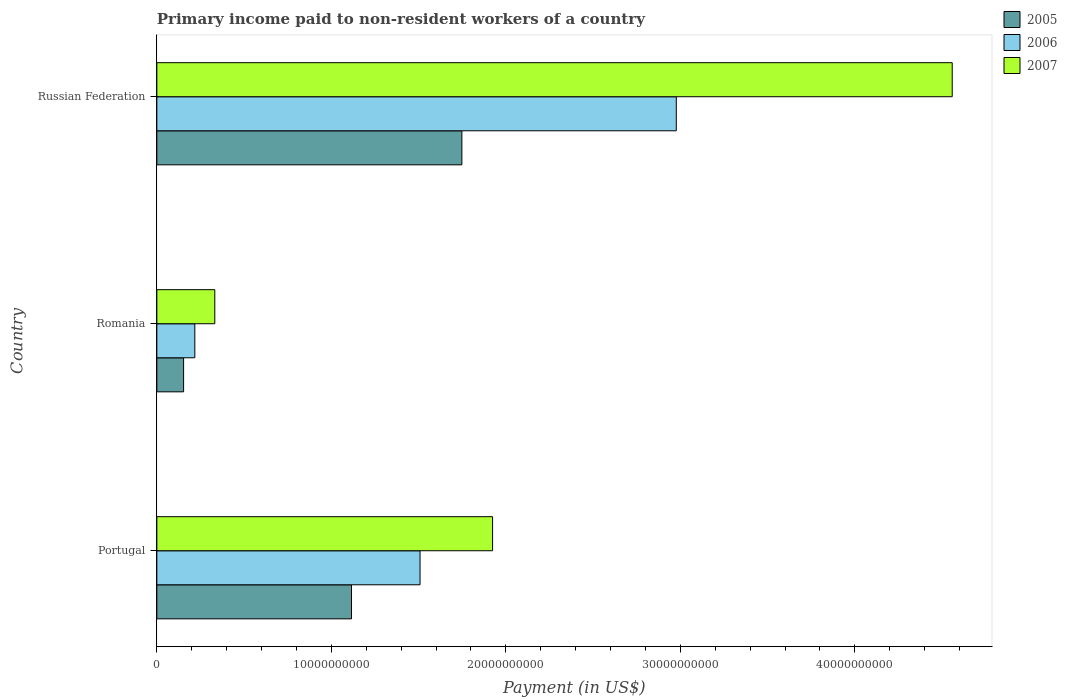How many different coloured bars are there?
Make the answer very short. 3. Are the number of bars per tick equal to the number of legend labels?
Your response must be concise. Yes. Are the number of bars on each tick of the Y-axis equal?
Offer a terse response. Yes. How many bars are there on the 2nd tick from the top?
Ensure brevity in your answer.  3. What is the amount paid to workers in 2005 in Russian Federation?
Your response must be concise. 1.75e+1. Across all countries, what is the maximum amount paid to workers in 2007?
Offer a very short reply. 4.56e+1. Across all countries, what is the minimum amount paid to workers in 2007?
Offer a terse response. 3.32e+09. In which country was the amount paid to workers in 2005 maximum?
Your answer should be very brief. Russian Federation. In which country was the amount paid to workers in 2007 minimum?
Keep it short and to the point. Romania. What is the total amount paid to workers in 2005 in the graph?
Provide a succinct answer. 3.02e+1. What is the difference between the amount paid to workers in 2007 in Portugal and that in Russian Federation?
Offer a very short reply. -2.63e+1. What is the difference between the amount paid to workers in 2007 in Romania and the amount paid to workers in 2005 in Russian Federation?
Your response must be concise. -1.42e+1. What is the average amount paid to workers in 2005 per country?
Provide a short and direct response. 1.01e+1. What is the difference between the amount paid to workers in 2006 and amount paid to workers in 2005 in Romania?
Your answer should be very brief. 6.44e+08. In how many countries, is the amount paid to workers in 2007 greater than 12000000000 US$?
Ensure brevity in your answer.  2. What is the ratio of the amount paid to workers in 2007 in Portugal to that in Romania?
Keep it short and to the point. 5.79. Is the amount paid to workers in 2006 in Romania less than that in Russian Federation?
Your answer should be very brief. Yes. What is the difference between the highest and the second highest amount paid to workers in 2007?
Offer a terse response. 2.63e+1. What is the difference between the highest and the lowest amount paid to workers in 2007?
Your response must be concise. 4.23e+1. Is the sum of the amount paid to workers in 2006 in Romania and Russian Federation greater than the maximum amount paid to workers in 2005 across all countries?
Provide a succinct answer. Yes. What does the 1st bar from the bottom in Portugal represents?
Offer a terse response. 2005. How many bars are there?
Your answer should be compact. 9. Are all the bars in the graph horizontal?
Give a very brief answer. Yes. How many countries are there in the graph?
Your answer should be very brief. 3. What is the difference between two consecutive major ticks on the X-axis?
Your response must be concise. 1.00e+1. Does the graph contain grids?
Your response must be concise. No. Where does the legend appear in the graph?
Offer a terse response. Top right. How many legend labels are there?
Provide a succinct answer. 3. How are the legend labels stacked?
Your answer should be compact. Vertical. What is the title of the graph?
Ensure brevity in your answer.  Primary income paid to non-resident workers of a country. What is the label or title of the X-axis?
Make the answer very short. Payment (in US$). What is the label or title of the Y-axis?
Your response must be concise. Country. What is the Payment (in US$) of 2005 in Portugal?
Ensure brevity in your answer.  1.12e+1. What is the Payment (in US$) of 2006 in Portugal?
Provide a succinct answer. 1.51e+1. What is the Payment (in US$) in 2007 in Portugal?
Provide a short and direct response. 1.92e+1. What is the Payment (in US$) in 2005 in Romania?
Your answer should be very brief. 1.53e+09. What is the Payment (in US$) in 2006 in Romania?
Ensure brevity in your answer.  2.18e+09. What is the Payment (in US$) in 2007 in Romania?
Give a very brief answer. 3.32e+09. What is the Payment (in US$) in 2005 in Russian Federation?
Give a very brief answer. 1.75e+1. What is the Payment (in US$) of 2006 in Russian Federation?
Offer a terse response. 2.98e+1. What is the Payment (in US$) of 2007 in Russian Federation?
Keep it short and to the point. 4.56e+1. Across all countries, what is the maximum Payment (in US$) in 2005?
Ensure brevity in your answer.  1.75e+1. Across all countries, what is the maximum Payment (in US$) in 2006?
Offer a terse response. 2.98e+1. Across all countries, what is the maximum Payment (in US$) of 2007?
Your answer should be very brief. 4.56e+1. Across all countries, what is the minimum Payment (in US$) of 2005?
Provide a short and direct response. 1.53e+09. Across all countries, what is the minimum Payment (in US$) in 2006?
Keep it short and to the point. 2.18e+09. Across all countries, what is the minimum Payment (in US$) of 2007?
Your answer should be compact. 3.32e+09. What is the total Payment (in US$) in 2005 in the graph?
Offer a very short reply. 3.02e+1. What is the total Payment (in US$) of 2006 in the graph?
Your response must be concise. 4.70e+1. What is the total Payment (in US$) of 2007 in the graph?
Offer a very short reply. 6.81e+1. What is the difference between the Payment (in US$) of 2005 in Portugal and that in Romania?
Ensure brevity in your answer.  9.62e+09. What is the difference between the Payment (in US$) in 2006 in Portugal and that in Romania?
Your answer should be compact. 1.29e+1. What is the difference between the Payment (in US$) in 2007 in Portugal and that in Romania?
Keep it short and to the point. 1.59e+1. What is the difference between the Payment (in US$) of 2005 in Portugal and that in Russian Federation?
Offer a very short reply. -6.33e+09. What is the difference between the Payment (in US$) in 2006 in Portugal and that in Russian Federation?
Give a very brief answer. -1.47e+1. What is the difference between the Payment (in US$) in 2007 in Portugal and that in Russian Federation?
Make the answer very short. -2.63e+1. What is the difference between the Payment (in US$) of 2005 in Romania and that in Russian Federation?
Provide a succinct answer. -1.59e+1. What is the difference between the Payment (in US$) of 2006 in Romania and that in Russian Federation?
Offer a terse response. -2.76e+1. What is the difference between the Payment (in US$) in 2007 in Romania and that in Russian Federation?
Make the answer very short. -4.23e+1. What is the difference between the Payment (in US$) of 2005 in Portugal and the Payment (in US$) of 2006 in Romania?
Provide a succinct answer. 8.98e+09. What is the difference between the Payment (in US$) of 2005 in Portugal and the Payment (in US$) of 2007 in Romania?
Keep it short and to the point. 7.83e+09. What is the difference between the Payment (in US$) of 2006 in Portugal and the Payment (in US$) of 2007 in Romania?
Your response must be concise. 1.18e+1. What is the difference between the Payment (in US$) in 2005 in Portugal and the Payment (in US$) in 2006 in Russian Federation?
Your answer should be compact. -1.86e+1. What is the difference between the Payment (in US$) of 2005 in Portugal and the Payment (in US$) of 2007 in Russian Federation?
Make the answer very short. -3.44e+1. What is the difference between the Payment (in US$) of 2006 in Portugal and the Payment (in US$) of 2007 in Russian Federation?
Give a very brief answer. -3.05e+1. What is the difference between the Payment (in US$) of 2005 in Romania and the Payment (in US$) of 2006 in Russian Federation?
Provide a short and direct response. -2.82e+1. What is the difference between the Payment (in US$) of 2005 in Romania and the Payment (in US$) of 2007 in Russian Federation?
Provide a short and direct response. -4.41e+1. What is the difference between the Payment (in US$) of 2006 in Romania and the Payment (in US$) of 2007 in Russian Federation?
Your answer should be compact. -4.34e+1. What is the average Payment (in US$) of 2005 per country?
Your answer should be very brief. 1.01e+1. What is the average Payment (in US$) in 2006 per country?
Provide a short and direct response. 1.57e+1. What is the average Payment (in US$) of 2007 per country?
Your answer should be compact. 2.27e+1. What is the difference between the Payment (in US$) in 2005 and Payment (in US$) in 2006 in Portugal?
Provide a short and direct response. -3.93e+09. What is the difference between the Payment (in US$) in 2005 and Payment (in US$) in 2007 in Portugal?
Your answer should be compact. -8.09e+09. What is the difference between the Payment (in US$) in 2006 and Payment (in US$) in 2007 in Portugal?
Your response must be concise. -4.16e+09. What is the difference between the Payment (in US$) of 2005 and Payment (in US$) of 2006 in Romania?
Offer a very short reply. -6.44e+08. What is the difference between the Payment (in US$) of 2005 and Payment (in US$) of 2007 in Romania?
Offer a very short reply. -1.79e+09. What is the difference between the Payment (in US$) of 2006 and Payment (in US$) of 2007 in Romania?
Give a very brief answer. -1.14e+09. What is the difference between the Payment (in US$) of 2005 and Payment (in US$) of 2006 in Russian Federation?
Ensure brevity in your answer.  -1.23e+1. What is the difference between the Payment (in US$) in 2005 and Payment (in US$) in 2007 in Russian Federation?
Provide a short and direct response. -2.81e+1. What is the difference between the Payment (in US$) in 2006 and Payment (in US$) in 2007 in Russian Federation?
Your answer should be compact. -1.58e+1. What is the ratio of the Payment (in US$) in 2005 in Portugal to that in Romania?
Your answer should be compact. 7.28. What is the ratio of the Payment (in US$) in 2006 in Portugal to that in Romania?
Your answer should be compact. 6.93. What is the ratio of the Payment (in US$) of 2007 in Portugal to that in Romania?
Your response must be concise. 5.79. What is the ratio of the Payment (in US$) in 2005 in Portugal to that in Russian Federation?
Offer a terse response. 0.64. What is the ratio of the Payment (in US$) in 2006 in Portugal to that in Russian Federation?
Offer a terse response. 0.51. What is the ratio of the Payment (in US$) in 2007 in Portugal to that in Russian Federation?
Your answer should be compact. 0.42. What is the ratio of the Payment (in US$) of 2005 in Romania to that in Russian Federation?
Offer a very short reply. 0.09. What is the ratio of the Payment (in US$) of 2006 in Romania to that in Russian Federation?
Make the answer very short. 0.07. What is the ratio of the Payment (in US$) of 2007 in Romania to that in Russian Federation?
Keep it short and to the point. 0.07. What is the difference between the highest and the second highest Payment (in US$) of 2005?
Ensure brevity in your answer.  6.33e+09. What is the difference between the highest and the second highest Payment (in US$) in 2006?
Offer a terse response. 1.47e+1. What is the difference between the highest and the second highest Payment (in US$) of 2007?
Offer a terse response. 2.63e+1. What is the difference between the highest and the lowest Payment (in US$) of 2005?
Ensure brevity in your answer.  1.59e+1. What is the difference between the highest and the lowest Payment (in US$) in 2006?
Offer a very short reply. 2.76e+1. What is the difference between the highest and the lowest Payment (in US$) in 2007?
Your answer should be compact. 4.23e+1. 